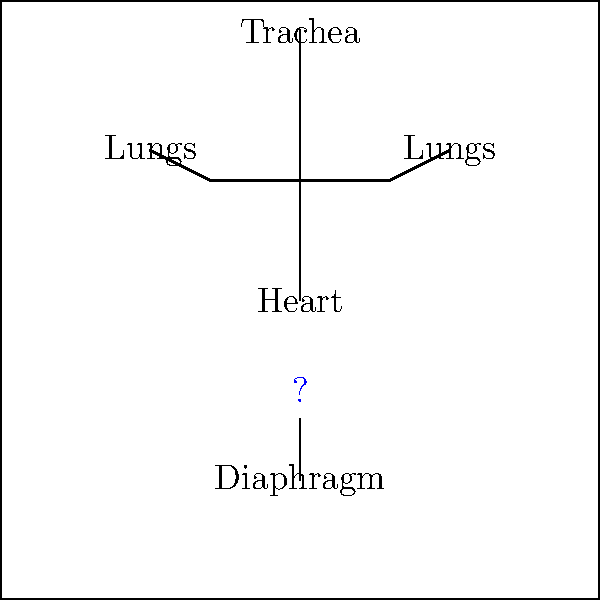In the labeled diagram of the human respiratory system, which crucial structure is represented by the blue question mark, connecting the heart to the diaphragm? To answer this question, let's analyze the diagram step-by-step:

1. We can see a simplified representation of the human respiratory system.
2. The diagram shows the following labeled structures:
   - Heart (center)
   - Lungs (on both sides of the heart)
   - Diaphragm (below the heart)
   - Trachea (at the top)
3. There's a blue question mark between the heart and the diaphragm.
4. This area represents a crucial structure in the respiratory system that connects these two organs.
5. The structure in question is responsible for pumping deoxygenated blood from the heart to the lungs and oxygenated blood from the lungs back to the heart.
6. This description matches the function of the pulmonary trunk and pulmonary veins, collectively known as the pulmonary vessels.

Given the patient's eagerness to understand their medical team, knowing this structure is crucial as it plays a vital role in the circulation of blood between the heart and lungs, which is essential for proper oxygenation of the body.
Answer: Pulmonary vessels 